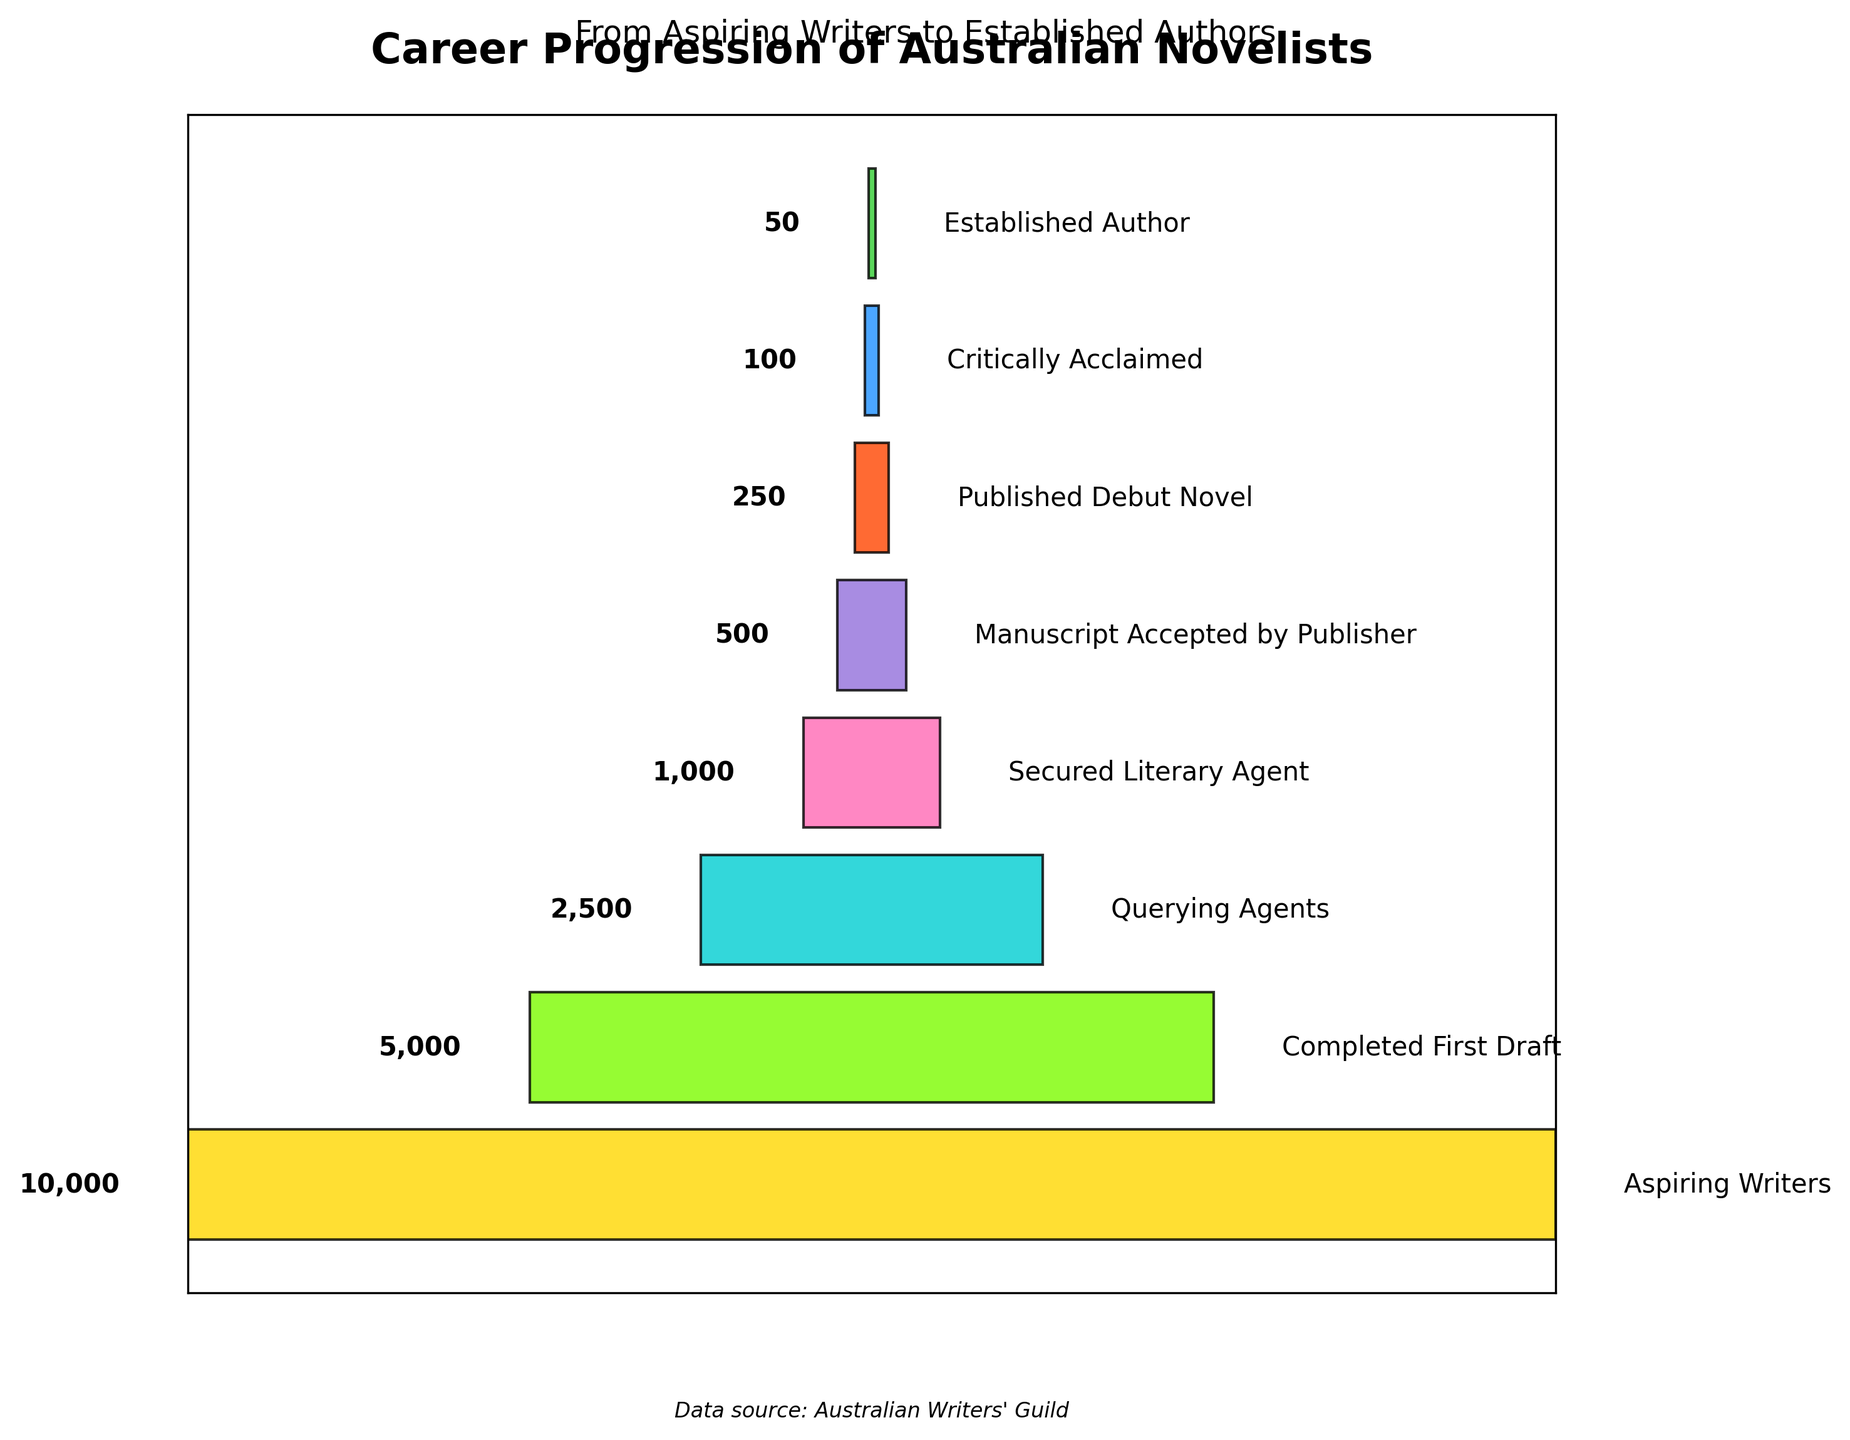What is the title of the figure? The title is located at the top of the figure and reads "Career Progression of Australian Novelists".
Answer: Career Progression of Australian Novelists How many stages are depicted in the funnel chart? To determine the number of stages, count the different labeled bars in the funnel chart.
Answer: 8 What is the number of writers in the "Published Debut Novel" stage? The "Published Debut Novel" stage is labeled in the figure with its corresponding value.
Answer: 250 How many more writers are "Completed First Draft" compared to "Secured Literary Agent"? Subtract the number of writers in the "Secured Literary Agent" stage from those in the "Completed First Draft" stage (5000 - 1000).
Answer: 4000 What is the smallest group depicted in the funnel chart? The smallest group will be the one with the smallest bar, labeled "Established Author".
Answer: Established Author Which stage has exactly half the number of writers as the "Completed First Draft" stage? Calculate the number of writers in the "Completed First Draft" stage divided by 2 (5000 / 2 = 2500), and see which stage matches this number, which is "Querying Agents".
Answer: Querying Agents How many writers are there from "Aspiring Writers" to "Manuscript Accepted by Publisher" combined? Add the number of writers in these stages: Aspiring Writers (10000) + Completed First Draft (5000) + Querying Agents (2500) + Secured Literary Agent (1000) + Manuscript Accepted by Publisher (500) = 19000.
Answer: 19000 Is the number of writers "Critically Acclaimed" more or less than a quarter of the number of "Aspiring Writers"? Calculate a quarter of the "Aspiring Writers" (10000 / 4 = 2500) and compare it to the "Critically Acclaimed" stage (100). The "Critically Acclaimed" number is less.
Answer: Less Which stages have fewer than 1000 writers? Identify the stages with writer numbers less than 1000: Secured Literary Agent (1000), Manuscript Accepted by Publisher (500), Published Debut Novel (250), Critically Acclaimed (100), Established Author (50).
Answer: Secured Literary Agent, Manuscript Accepted by Publisher, Published Debut Novel, Critically Acclaimed, Established Author What is the difference between the largest and smallest group of writers in the funnel chart? Subtract the number of writers in the smallest group ("Established Author" 50) from the largest group ("Aspiring Writers" 10000), which is 10000 - 50.
Answer: 9950 